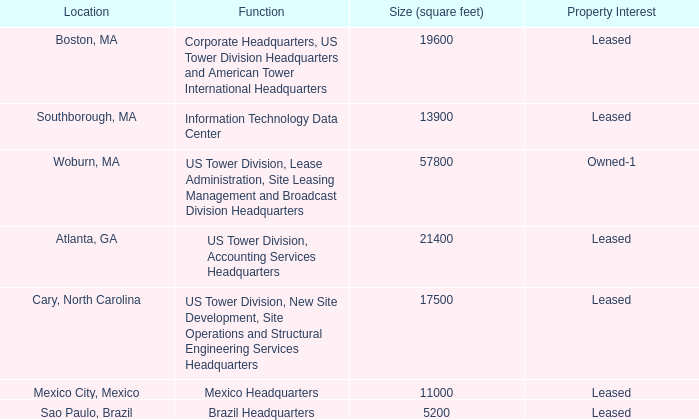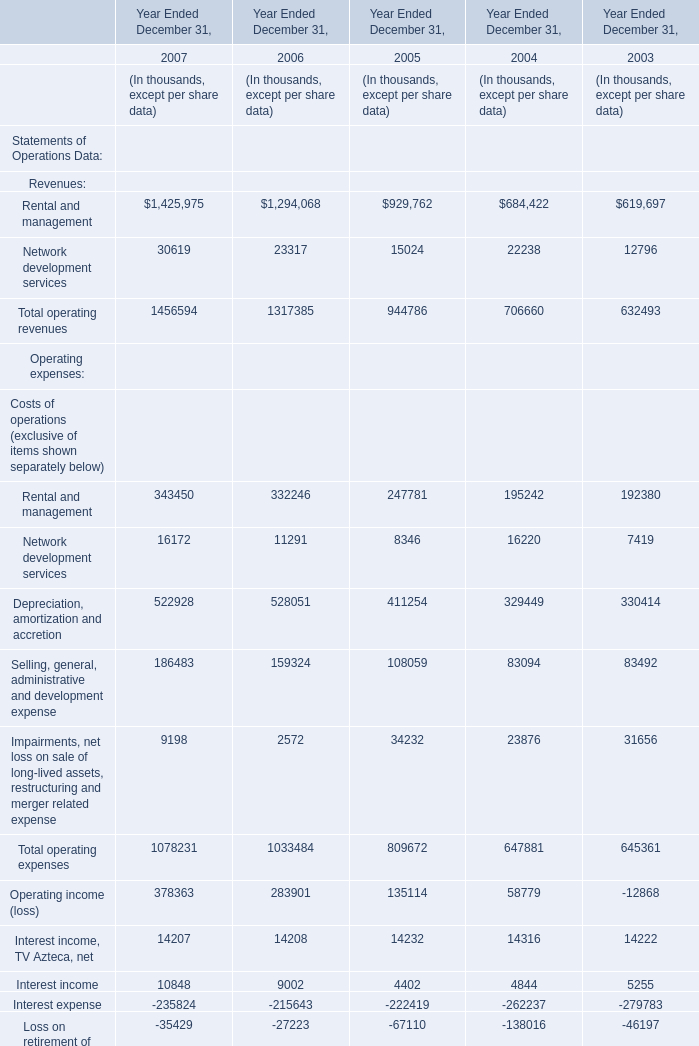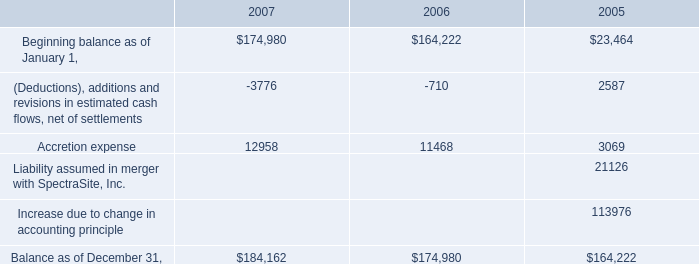what is the square footage of properties in massachusetts?\\n\\n 
Computations: ((19600 + 13900) + 57800)
Answer: 91300.0. 